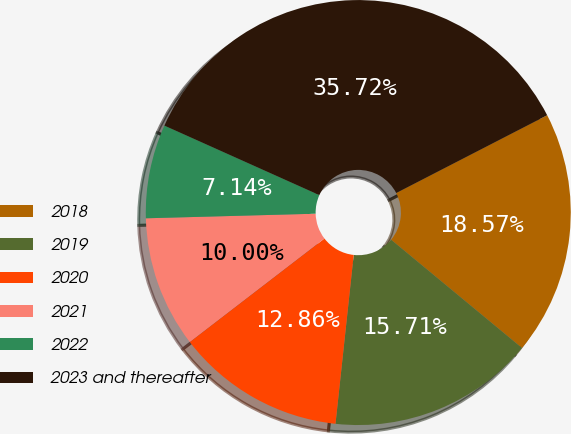<chart> <loc_0><loc_0><loc_500><loc_500><pie_chart><fcel>2018<fcel>2019<fcel>2020<fcel>2021<fcel>2022<fcel>2023 and thereafter<nl><fcel>18.57%<fcel>15.71%<fcel>12.86%<fcel>10.0%<fcel>7.14%<fcel>35.72%<nl></chart> 